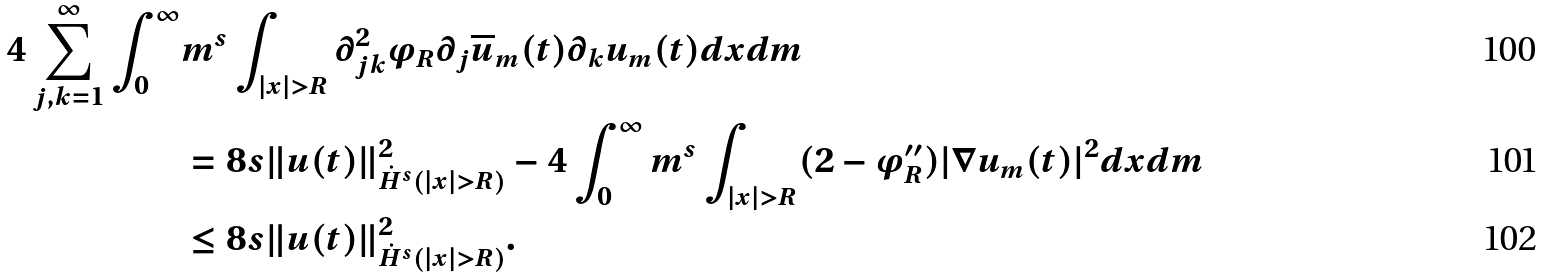<formula> <loc_0><loc_0><loc_500><loc_500>4 \sum _ { j , k = 1 } ^ { \infty } \int _ { 0 } ^ { \infty } & m ^ { s } \int _ { | x | > R } \partial ^ { 2 } _ { j k } \varphi _ { R } \partial _ { j } \overline { u } _ { m } ( t ) \partial _ { k } u _ { m } ( t ) d x d m \\ & = 8 s \| u ( t ) \| ^ { 2 } _ { \dot { H } ^ { s } ( | x | > R ) } - 4 \int _ { 0 } ^ { \infty } m ^ { s } \int _ { | x | > R } ( 2 - \varphi ^ { \prime \prime } _ { R } ) | \nabla u _ { m } ( t ) | ^ { 2 } d x d m \\ & \leq 8 s \| u ( t ) \| ^ { 2 } _ { \dot { H } ^ { s } ( | x | > R ) } .</formula> 